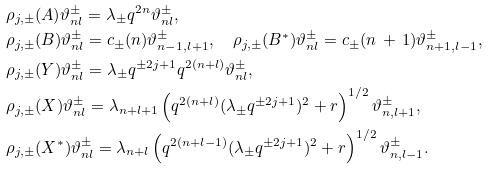Convert formula to latex. <formula><loc_0><loc_0><loc_500><loc_500>& \rho _ { j , \pm } ( A ) \vartheta ^ { \pm } _ { n l } = \lambda _ { \pm } q ^ { 2 n } \vartheta ^ { \pm } _ { n l } , \\ & \rho _ { j , \pm } ( B ) \vartheta ^ { \pm } _ { n l } = c _ { \pm } ( n ) \vartheta ^ { \pm } _ { n - 1 , l + 1 } , \quad \rho _ { j , \pm } ( B ^ { \ast } ) \vartheta ^ { \pm } _ { n l } = c _ { \pm } ( n \, + \, 1 ) \vartheta ^ { \pm } _ { n + 1 , l - 1 } , \\ & \rho _ { j , \pm } ( Y ) \vartheta ^ { \pm } _ { n l } = \lambda _ { \pm } q ^ { \pm 2 j + 1 } q ^ { 2 ( n + l ) } \vartheta ^ { \pm } _ { n l } , \\ & \rho _ { j , \pm } ( X ) \vartheta ^ { \pm } _ { n l } = \lambda _ { n + l + 1 } \left ( q ^ { 2 ( n + l ) } ( \lambda _ { \pm } q ^ { \pm 2 j + 1 } ) ^ { 2 } + r \right ) ^ { 1 / 2 } \vartheta ^ { \pm } _ { n , l + 1 } , \\ & \rho _ { j , \pm } ( X ^ { \ast } ) \vartheta ^ { \pm } _ { n l } = \lambda _ { n + l } \left ( q ^ { 2 ( n + l - 1 ) } ( \lambda _ { \pm } q ^ { \pm 2 j + 1 } ) ^ { 2 } + r \right ) ^ { 1 / 2 } \vartheta ^ { \pm } _ { n , l - 1 } .</formula> 